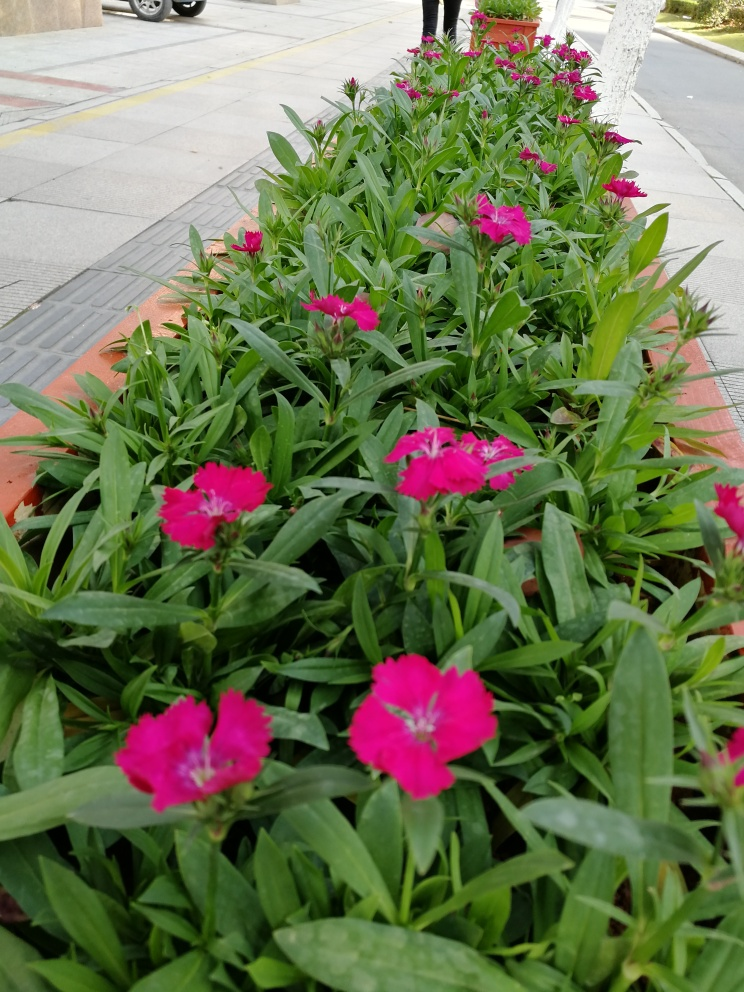What time of day does this photo seem to have been taken? Given the diffused lighting and lack of strong shadows, this photo seems to have been taken on an overcast day or during a time when the sun was shielded by clouds. 